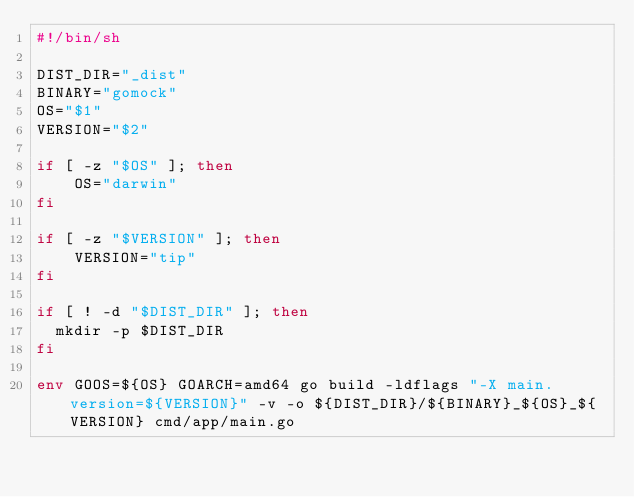Convert code to text. <code><loc_0><loc_0><loc_500><loc_500><_Bash_>#!/bin/sh

DIST_DIR="_dist"
BINARY="gomock"
OS="$1"
VERSION="$2"

if [ -z "$OS" ]; then
    OS="darwin"
fi

if [ -z "$VERSION" ]; then
    VERSION="tip"
fi

if [ ! -d "$DIST_DIR" ]; then
  mkdir -p $DIST_DIR
fi

env GOOS=${OS} GOARCH=amd64 go build -ldflags "-X main.version=${VERSION}" -v -o ${DIST_DIR}/${BINARY}_${OS}_${VERSION} cmd/app/main.go</code> 